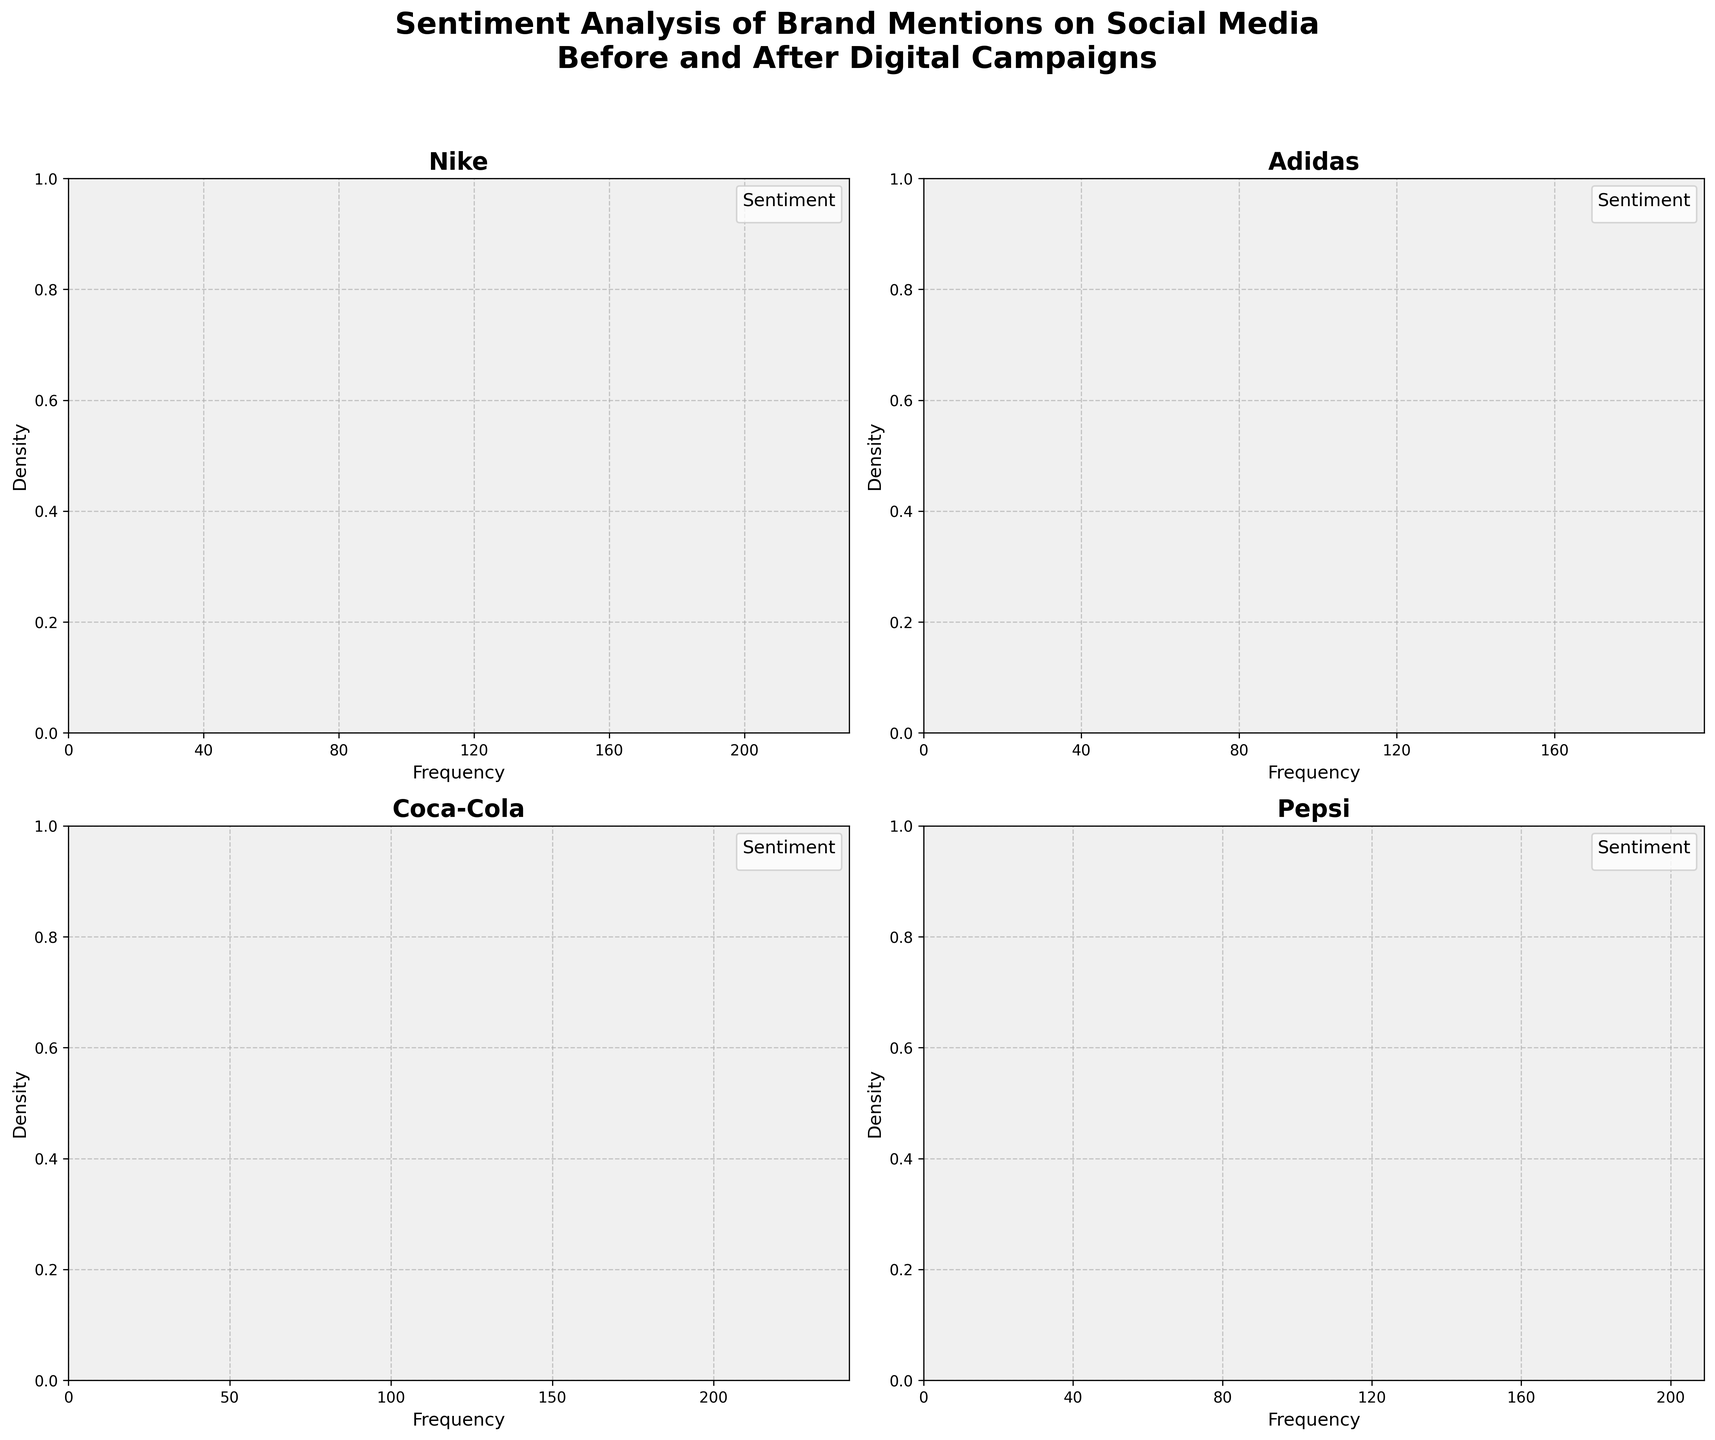What is the title of the plot? The title of the plot is displayed at the top and summarizes what the figure represents: "Sentiment Analysis of Brand Mentions on Social Media Before and After Digital Campaigns".
Answer: Sentiment Analysis of Brand Mentions on Social Media Before and After Digital Campaigns Which brand had the highest frequency of positive mentions after the campaign? Look at the plot for each brand and compare the peaks of the density curves for positive mentions in the "After" period. Nike has the highest peak, indicating the highest frequency.
Answer: Nike Which sentiment had the smallest change in frequency for Adidas from before to after the digital campaign? Compare the densities for each sentiment (Positive, Negative, Neutral) for Adidas before and after the campaign. The change for Negative mentions is the smallest.
Answer: Negative Did Coca-Cola's negative mentions increase or decrease after the campaign? By observing the density plot for Coca-Cola, compare the density of negative mentions before and after. Negative mentions decreased after the campaign.
Answer: Decrease Which brand showed the largest increase in neutral mentions after the campaign? Examine the density plot for each brand and compare the change in density for neutral mentions before and after the campaign. Pepsi shows the largest increase in neutral mentions.
Answer: Pepsi How does the frequency of negative mentions for Nike after the campaign compare to before? Compare the density peaks for negative mentions for Nike in the "Before" and "After" periods. The peak is lower after the campaign, indicating a decrease in frequency.
Answer: It decreased What is the primary color used for positive sentiment in the plot? Identify the color used consistently across different brands for the "Positive" sentiment in the legend. The color is a shade of green (#66c2a5).
Answer: Green Which time period (Before or After) generally had higher frequencies of neutral mentions across all brands? By examining the density plots for all brands, check if the peaks for neutral mentions are generally higher in the "Before" or "After" period. "After" period shows generally higher peaks for neutral mentions.
Answer: After 